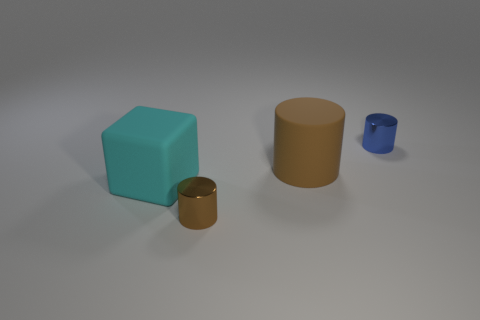Subtract all brown matte cylinders. How many cylinders are left? 2 Subtract all cyan balls. How many brown cylinders are left? 2 Add 1 tiny blue cylinders. How many objects exist? 5 Subtract 1 cylinders. How many cylinders are left? 2 Subtract all cylinders. How many objects are left? 1 Subtract all red blocks. Subtract all green cylinders. How many blocks are left? 1 Subtract all small brown objects. Subtract all cyan cubes. How many objects are left? 2 Add 3 big cubes. How many big cubes are left? 4 Add 2 brown matte cylinders. How many brown matte cylinders exist? 3 Subtract 0 red balls. How many objects are left? 4 